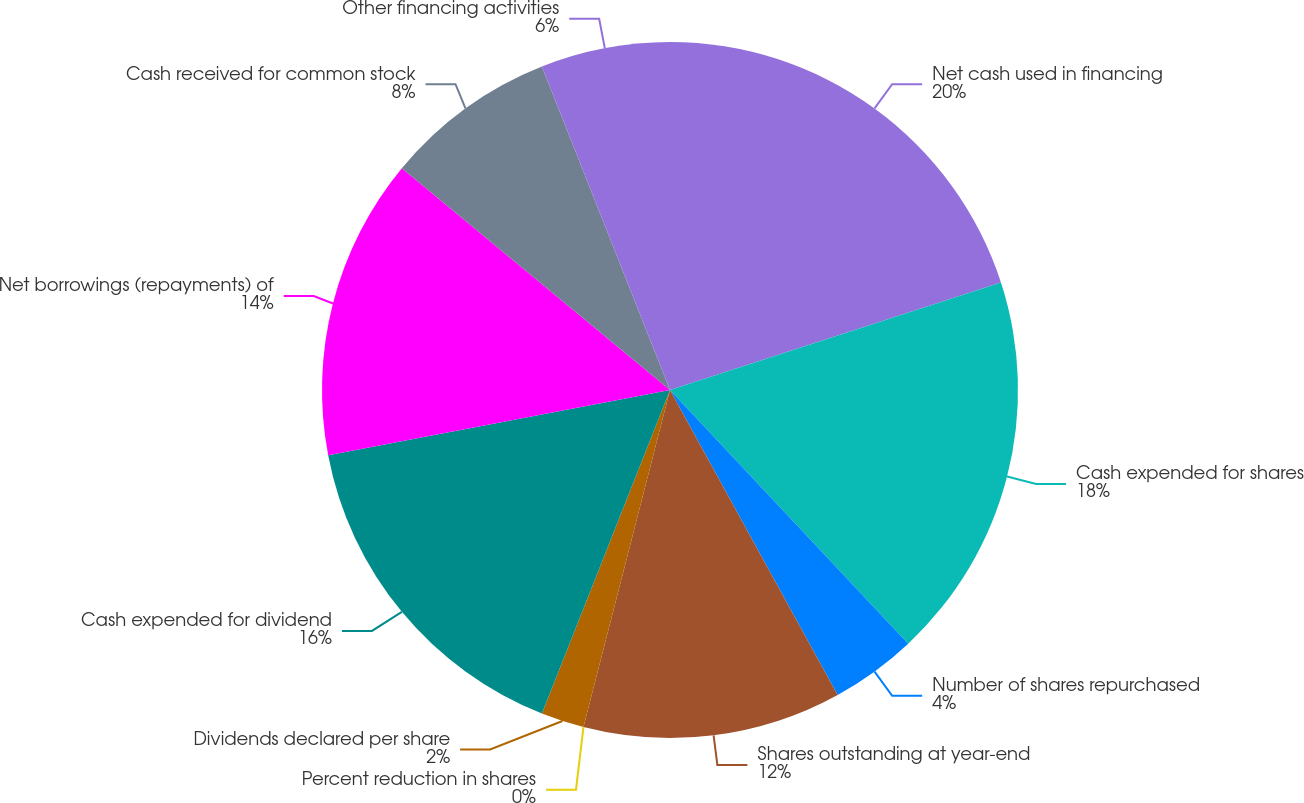<chart> <loc_0><loc_0><loc_500><loc_500><pie_chart><fcel>Net cash used in financing<fcel>Cash expended for shares<fcel>Number of shares repurchased<fcel>Shares outstanding at year-end<fcel>Percent reduction in shares<fcel>Dividends declared per share<fcel>Cash expended for dividend<fcel>Net borrowings (repayments) of<fcel>Cash received for common stock<fcel>Other financing activities<nl><fcel>20.0%<fcel>18.0%<fcel>4.0%<fcel>12.0%<fcel>0.0%<fcel>2.0%<fcel>16.0%<fcel>14.0%<fcel>8.0%<fcel>6.0%<nl></chart> 